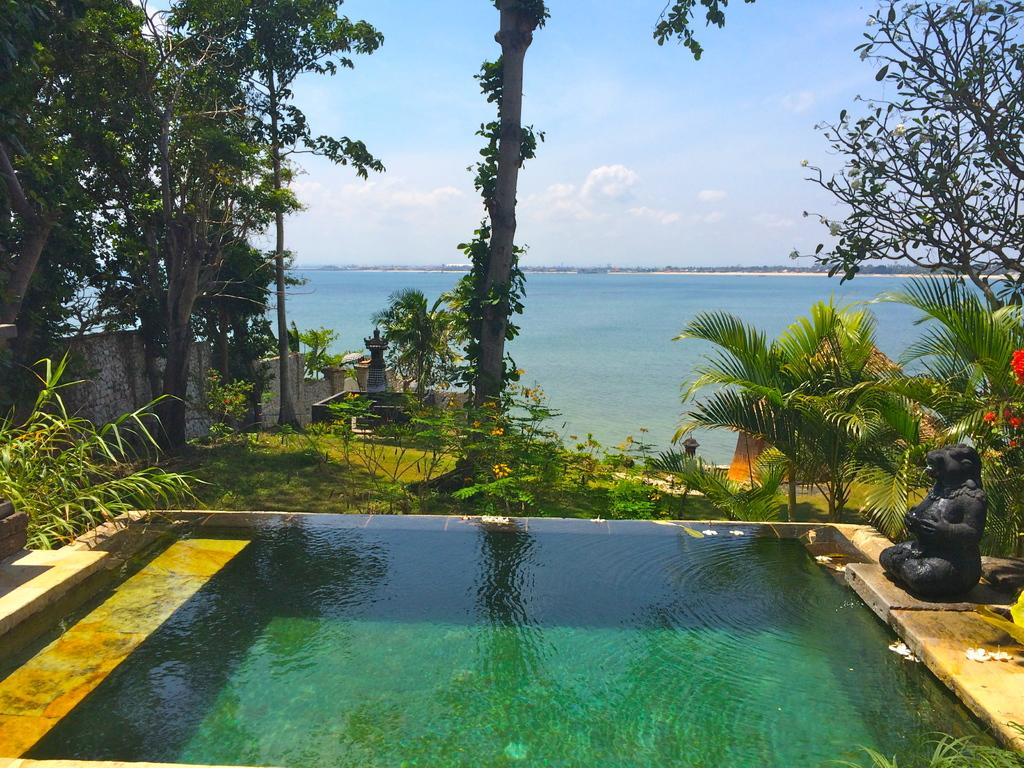What is the main subject in the image? There is a sculpture in the image. What type of flora can be seen in the image? There are flowers, plants, grass, and trees visible in the image. What type of water feature is present in the image? There is a swimming pool in the image. What part of the natural environment is visible in the image? The sky is visible in the image. What type of memory is being used to store the sculpture's design in the image? The image does not provide information about the sculpture's design or the type of memory used to store it. What type of neck accessory is being worn by the sculpture in the image? The sculpture is not a living being and therefore cannot wear any type of neck accessory. 